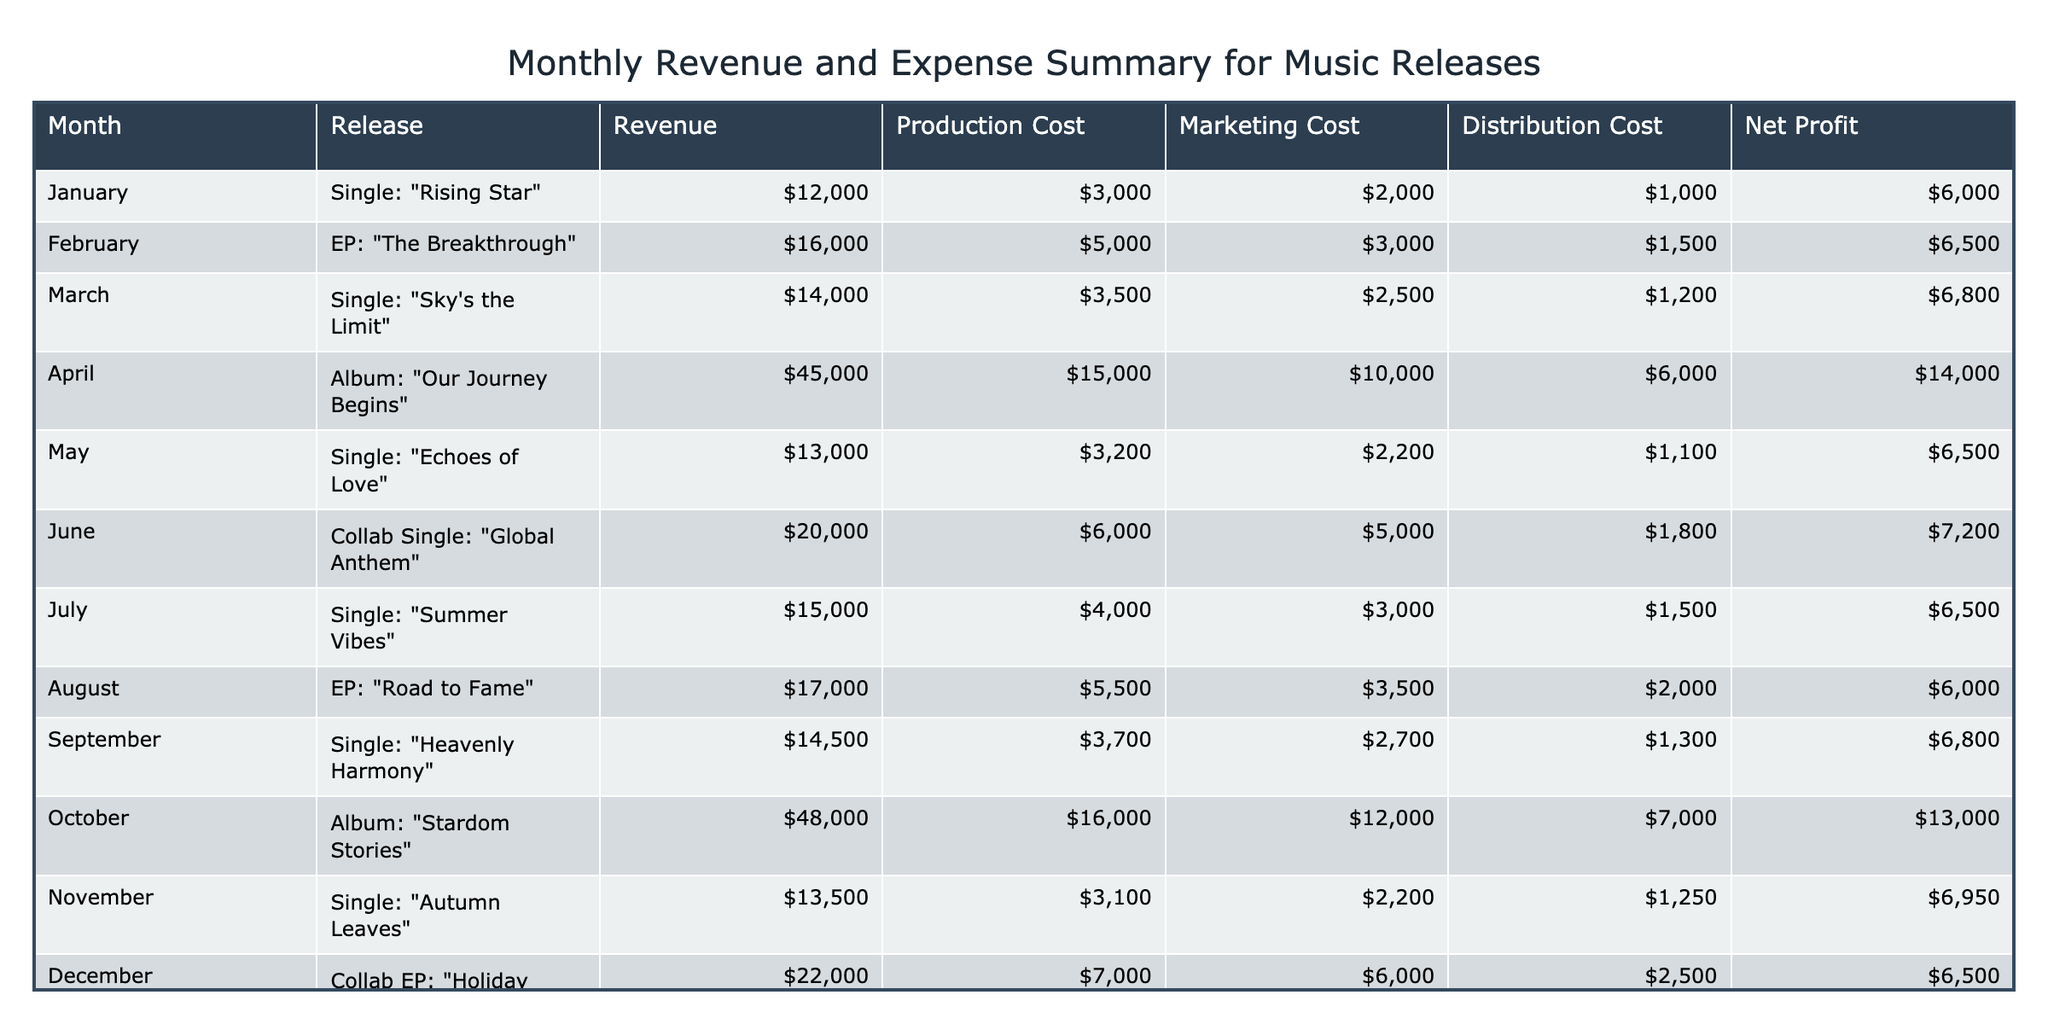What was the highest revenue month? The highest revenue in the table is recorded in October with a revenue of $48,000 from the album "Stardom Stories."
Answer: October Which release had the lowest net profit? The release with the lowest net profit is the EP "Road to Fame" in August, with a net profit of $6,000.
Answer: August What is the total production cost for all releases? To find the total production cost, add up each production cost: (3,000 + 5,000 + 3,500 + 15,000 + 3,200 + 6,000 + 4,000 + 5,500 + 3,700 + 16,000 + 3,100 + 7,000) = 66,000.
Answer: 66,000 Did the album "Our Journey Begins" generate more revenue than the collaboration EP "Holiday Cheers"? Yes, the album "Our Journey Begins" generated $45,000 while "Holiday Cheers" generated $22,000, demonstrating that the former had a higher revenue.
Answer: Yes What was the total net profit for the first half of the year? For the first half of the year (January to June), the net profits were: (6,000 + 6,500 + 6,800 + 14,000 + 6,500 + 7,200) = 46,000. Therefore, the total net profit is $46,000.
Answer: 46,000 Which month had the highest marketing cost, and what was that cost? The month with the highest marketing cost was April with a marketing cost of $10,000 for the album "Our Journey Begins."
Answer: April, $10,000 What is the average net profit across all releases? To find the average net profit, we sum the net profits: (6,000 + 6,500 + 6,800 + 14,000 + 6,500 + 7,200 + 6,500 + 6,000 + 6,800 + 13,000 + 6,950 + 6,500) =  80,000. There are 12 entries, so divide 80,000 by 12 to get approximately 6,667.
Answer: 6,667 Is the production cost for the single "Summer Vibes" lower than the production cost for "Echoes of Love"? Yes, "Summer Vibes" has a production cost of $4,000, which is less than "Echoes of Love," which cost $3,200.
Answer: No What’s the total distribution cost for all album releases? The total distribution cost for albums "Our Journey Begins," "Stardom Stories" is calculated as follows: (6,000 + 7,000) = 13,000.
Answer: 13,000 